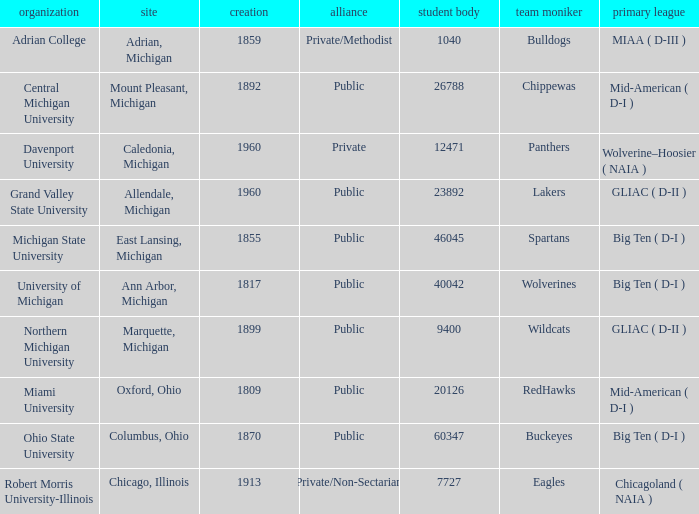What is the enrollment for the Redhawks? 1.0. 